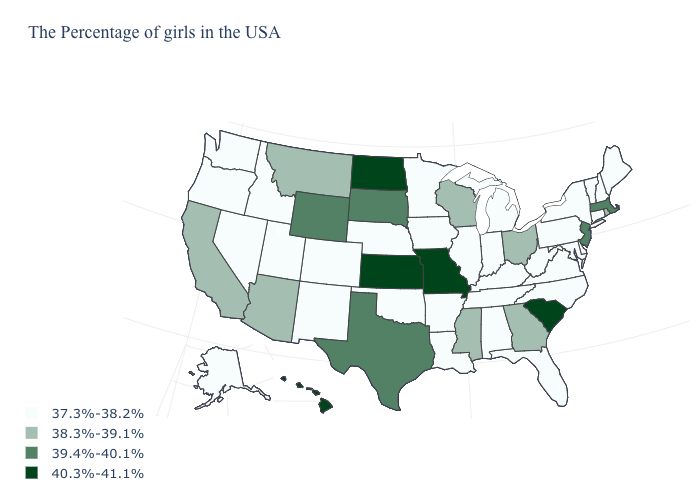Which states have the lowest value in the USA?
Give a very brief answer. Maine, New Hampshire, Vermont, Connecticut, New York, Delaware, Maryland, Pennsylvania, Virginia, North Carolina, West Virginia, Florida, Michigan, Kentucky, Indiana, Alabama, Tennessee, Illinois, Louisiana, Arkansas, Minnesota, Iowa, Nebraska, Oklahoma, Colorado, New Mexico, Utah, Idaho, Nevada, Washington, Oregon, Alaska. How many symbols are there in the legend?
Answer briefly. 4. What is the value of New Hampshire?
Write a very short answer. 37.3%-38.2%. Does the first symbol in the legend represent the smallest category?
Short answer required. Yes. Does Montana have a lower value than Washington?
Answer briefly. No. What is the value of Oregon?
Quick response, please. 37.3%-38.2%. Does the first symbol in the legend represent the smallest category?
Keep it brief. Yes. What is the value of Mississippi?
Give a very brief answer. 38.3%-39.1%. Name the states that have a value in the range 37.3%-38.2%?
Answer briefly. Maine, New Hampshire, Vermont, Connecticut, New York, Delaware, Maryland, Pennsylvania, Virginia, North Carolina, West Virginia, Florida, Michigan, Kentucky, Indiana, Alabama, Tennessee, Illinois, Louisiana, Arkansas, Minnesota, Iowa, Nebraska, Oklahoma, Colorado, New Mexico, Utah, Idaho, Nevada, Washington, Oregon, Alaska. Name the states that have a value in the range 38.3%-39.1%?
Write a very short answer. Rhode Island, Ohio, Georgia, Wisconsin, Mississippi, Montana, Arizona, California. Does Hawaii have the lowest value in the USA?
Give a very brief answer. No. Is the legend a continuous bar?
Short answer required. No. What is the lowest value in the USA?
Keep it brief. 37.3%-38.2%. Name the states that have a value in the range 39.4%-40.1%?
Concise answer only. Massachusetts, New Jersey, Texas, South Dakota, Wyoming. 